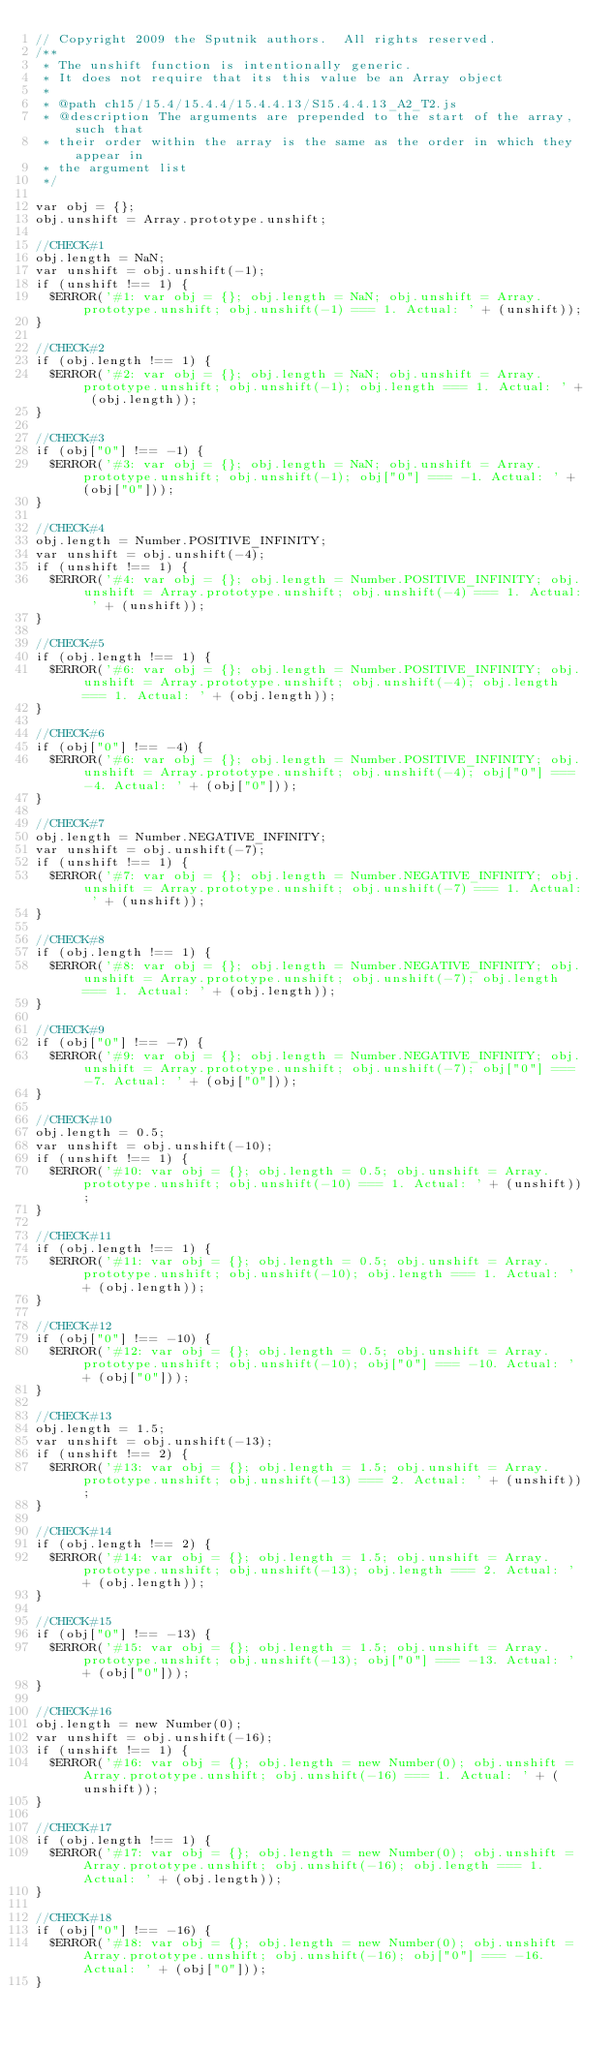Convert code to text. <code><loc_0><loc_0><loc_500><loc_500><_JavaScript_>// Copyright 2009 the Sputnik authors.  All rights reserved.
/**
 * The unshift function is intentionally generic.
 * It does not require that its this value be an Array object
 *
 * @path ch15/15.4/15.4.4/15.4.4.13/S15.4.4.13_A2_T2.js
 * @description The arguments are prepended to the start of the array, such that
 * their order within the array is the same as the order in which they appear in
 * the argument list
 */

var obj = {};
obj.unshift = Array.prototype.unshift;

//CHECK#1
obj.length = NaN;
var unshift = obj.unshift(-1);
if (unshift !== 1) {
  $ERROR('#1: var obj = {}; obj.length = NaN; obj.unshift = Array.prototype.unshift; obj.unshift(-1) === 1. Actual: ' + (unshift));
}

//CHECK#2
if (obj.length !== 1) {
  $ERROR('#2: var obj = {}; obj.length = NaN; obj.unshift = Array.prototype.unshift; obj.unshift(-1); obj.length === 1. Actual: ' + (obj.length));
}

//CHECK#3
if (obj["0"] !== -1) {
  $ERROR('#3: var obj = {}; obj.length = NaN; obj.unshift = Array.prototype.unshift; obj.unshift(-1); obj["0"] === -1. Actual: ' + (obj["0"]));
}

//CHECK#4
obj.length = Number.POSITIVE_INFINITY;
var unshift = obj.unshift(-4);
if (unshift !== 1) {
  $ERROR('#4: var obj = {}; obj.length = Number.POSITIVE_INFINITY; obj.unshift = Array.prototype.unshift; obj.unshift(-4) === 1. Actual: ' + (unshift));
}

//CHECK#5
if (obj.length !== 1) {
  $ERROR('#6: var obj = {}; obj.length = Number.POSITIVE_INFINITY; obj.unshift = Array.prototype.unshift; obj.unshift(-4); obj.length === 1. Actual: ' + (obj.length));
}

//CHECK#6
if (obj["0"] !== -4) {
  $ERROR('#6: var obj = {}; obj.length = Number.POSITIVE_INFINITY; obj.unshift = Array.prototype.unshift; obj.unshift(-4); obj["0"] === -4. Actual: ' + (obj["0"]));
}

//CHECK#7
obj.length = Number.NEGATIVE_INFINITY;
var unshift = obj.unshift(-7);
if (unshift !== 1) {
  $ERROR('#7: var obj = {}; obj.length = Number.NEGATIVE_INFINITY; obj.unshift = Array.prototype.unshift; obj.unshift(-7) === 1. Actual: ' + (unshift));
}

//CHECK#8
if (obj.length !== 1) {
  $ERROR('#8: var obj = {}; obj.length = Number.NEGATIVE_INFINITY; obj.unshift = Array.prototype.unshift; obj.unshift(-7); obj.length === 1. Actual: ' + (obj.length));
}

//CHECK#9
if (obj["0"] !== -7) {
  $ERROR('#9: var obj = {}; obj.length = Number.NEGATIVE_INFINITY; obj.unshift = Array.prototype.unshift; obj.unshift(-7); obj["0"] === -7. Actual: ' + (obj["0"]));
}

//CHECK#10
obj.length = 0.5;
var unshift = obj.unshift(-10);
if (unshift !== 1) {
  $ERROR('#10: var obj = {}; obj.length = 0.5; obj.unshift = Array.prototype.unshift; obj.unshift(-10) === 1. Actual: ' + (unshift));
}

//CHECK#11
if (obj.length !== 1) {
  $ERROR('#11: var obj = {}; obj.length = 0.5; obj.unshift = Array.prototype.unshift; obj.unshift(-10); obj.length === 1. Actual: ' + (obj.length));
} 

//CHECK#12
if (obj["0"] !== -10) {
  $ERROR('#12: var obj = {}; obj.length = 0.5; obj.unshift = Array.prototype.unshift; obj.unshift(-10); obj["0"] === -10. Actual: ' + (obj["0"]));
}

//CHECK#13
obj.length = 1.5;
var unshift = obj.unshift(-13);
if (unshift !== 2) {
  $ERROR('#13: var obj = {}; obj.length = 1.5; obj.unshift = Array.prototype.unshift; obj.unshift(-13) === 2. Actual: ' + (unshift));
}

//CHECK#14
if (obj.length !== 2) {
  $ERROR('#14: var obj = {}; obj.length = 1.5; obj.unshift = Array.prototype.unshift; obj.unshift(-13); obj.length === 2. Actual: ' + (obj.length));
} 

//CHECK#15
if (obj["0"] !== -13) {
  $ERROR('#15: var obj = {}; obj.length = 1.5; obj.unshift = Array.prototype.unshift; obj.unshift(-13); obj["0"] === -13. Actual: ' + (obj["0"]));
}

//CHECK#16
obj.length = new Number(0);
var unshift = obj.unshift(-16);
if (unshift !== 1) {
  $ERROR('#16: var obj = {}; obj.length = new Number(0); obj.unshift = Array.prototype.unshift; obj.unshift(-16) === 1. Actual: ' + (unshift));
}

//CHECK#17
if (obj.length !== 1) {
  $ERROR('#17: var obj = {}; obj.length = new Number(0); obj.unshift = Array.prototype.unshift; obj.unshift(-16); obj.length === 1. Actual: ' + (obj.length));
}

//CHECK#18
if (obj["0"] !== -16) {
  $ERROR('#18: var obj = {}; obj.length = new Number(0); obj.unshift = Array.prototype.unshift; obj.unshift(-16); obj["0"] === -16. Actual: ' + (obj["0"]));
}   

</code> 